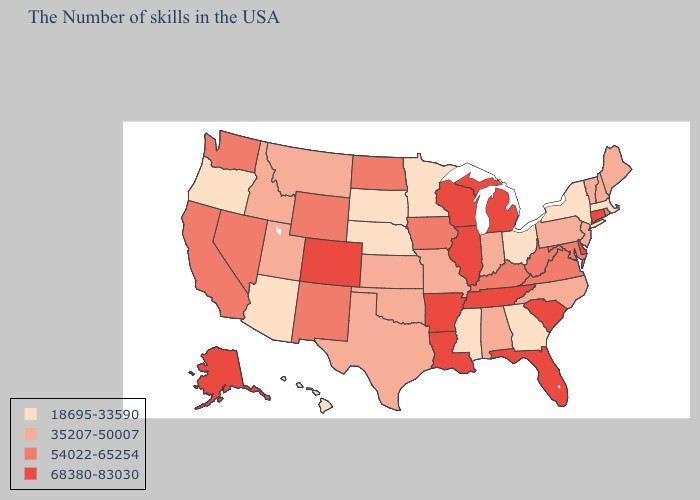What is the lowest value in the USA?
Keep it brief. 18695-33590. Does Montana have the lowest value in the West?
Short answer required. No. Name the states that have a value in the range 18695-33590?
Give a very brief answer. Massachusetts, New York, Ohio, Georgia, Mississippi, Minnesota, Nebraska, South Dakota, Arizona, Oregon, Hawaii. Does New York have the lowest value in the Northeast?
Be succinct. Yes. Among the states that border Minnesota , does South Dakota have the highest value?
Short answer required. No. Does New York have the lowest value in the Northeast?
Short answer required. Yes. Is the legend a continuous bar?
Write a very short answer. No. Which states hav the highest value in the West?
Give a very brief answer. Colorado, Alaska. Does the map have missing data?
Concise answer only. No. What is the value of Maryland?
Answer briefly. 54022-65254. What is the value of New Hampshire?
Short answer required. 35207-50007. Name the states that have a value in the range 18695-33590?
Concise answer only. Massachusetts, New York, Ohio, Georgia, Mississippi, Minnesota, Nebraska, South Dakota, Arizona, Oregon, Hawaii. What is the lowest value in the MidWest?
Answer briefly. 18695-33590. What is the highest value in the USA?
Short answer required. 68380-83030. Does Alaska have the same value as Virginia?
Short answer required. No. 